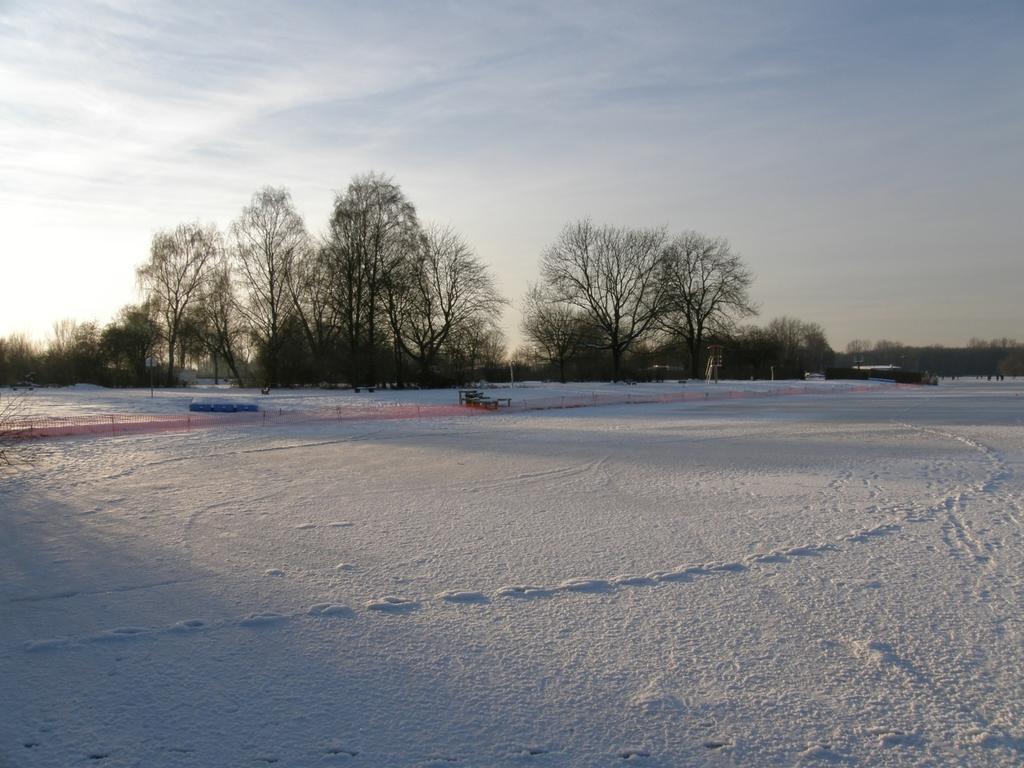In one or two sentences, can you explain what this image depicts? In this image I can see the snow on the ground. In the background I can see few trees, few other objects and the sky. 